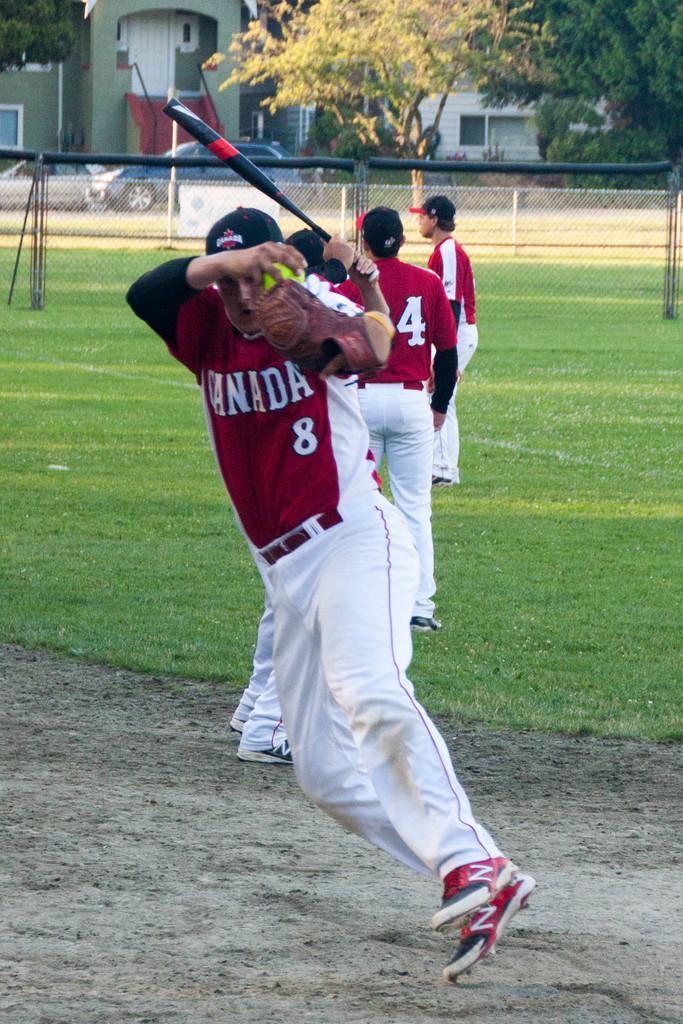What is the boys jersey number?
Your response must be concise. 8. 